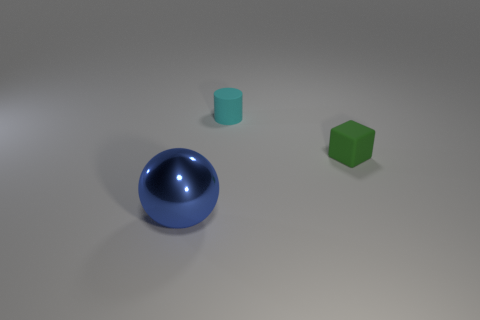Add 3 matte cubes. How many objects exist? 6 Subtract all spheres. How many objects are left? 2 Subtract 1 balls. How many balls are left? 0 Subtract all brown cylinders. Subtract all red cubes. How many cylinders are left? 1 Subtract all green objects. Subtract all blue metal spheres. How many objects are left? 1 Add 1 cyan matte things. How many cyan matte things are left? 2 Add 3 shiny spheres. How many shiny spheres exist? 4 Subtract 0 brown spheres. How many objects are left? 3 